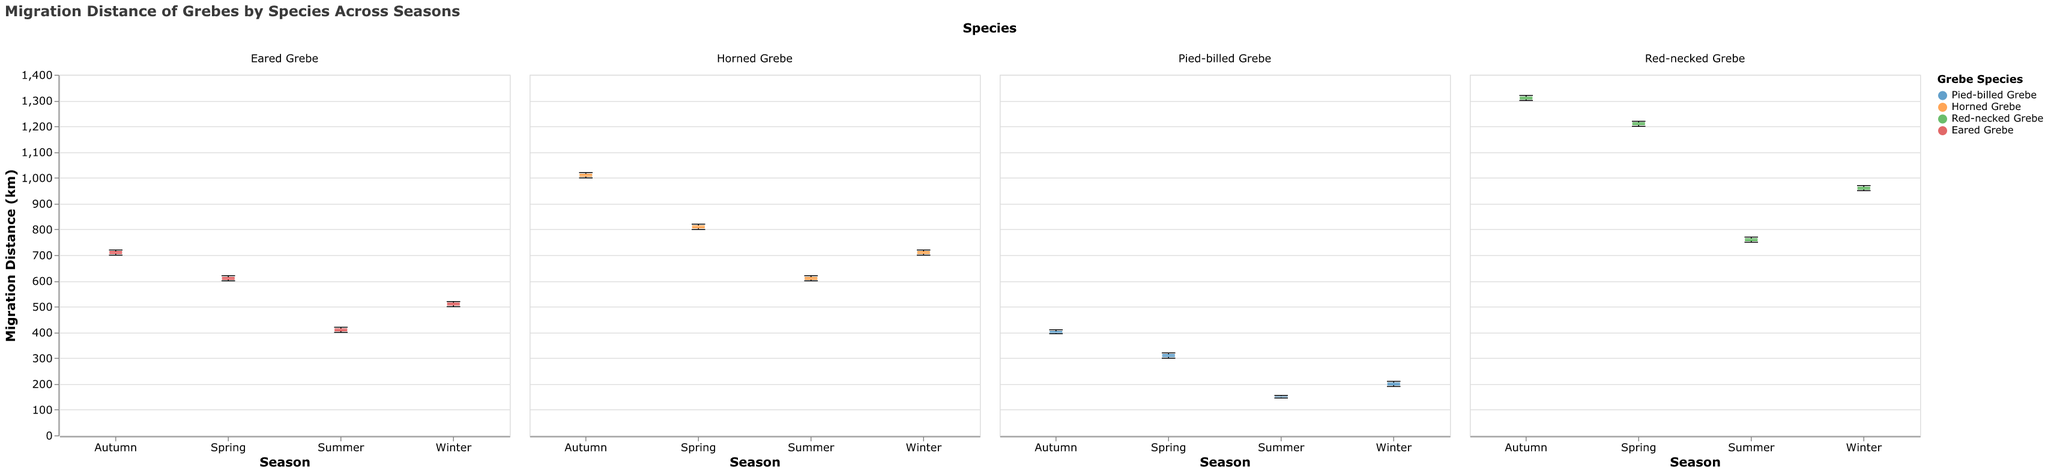Which species shows the highest median migration distance? The box plot's central line represents the median migration distance for each species across different seasons. The Red-necked Grebe has the highest median value compared to the other species.
Answer: Red-necked Grebe In which season does the Pied-billed Grebe have the lowest migration distance? By observing the box plots for the Pied-billed Grebe, the Summer season box plot has the lowest range of migration distances.
Answer: Summer What is the median migration distance for the Eared Grebe during Autumn? Find the Autumn box plot for the Eared Grebe and look at the central line for its median value. The median line is at 710 km.
Answer: 710 km Among all seasons, which species has the widest range of migration distances? The range is indicated by the length from the minimum to the maximum value in each box plot. The Red-necked Grebe in Autumn has a wider spread compared to other species and seasons.
Answer: Red-necked Grebe in Autumn How does the migration distance of Horned Grebes in Winter compare to those in Summer? To compare, look at the box plots for Winter and Summer for Horned Grebes. Winter migration distances are higher, as the boxes are positioned higher on the y-axis compared to Summer.
Answer: Winter distances are higher Which season shows the highest median migration distance across all species? Look at the median lines of all species in each season's box plots. The highest median lines appear during Autumn for species like Red-necked Grebe and Horned Grebe.
Answer: Autumn Are Eared Grebes' migration distances in Spring higher or lower than those in Winter? Compare the box plot for Eared Grebes in Spring with the one in Winter. The Spring distances are higher, as indicated by the overall higher position of the box plot.
Answer: Higher What is the range of migration distances for Pied-billed Grebes in Autumn? Find the minimum and maximum points of the Autumn box plot for Pied-billed Grebes. The minimum value is 395 km, and the maximum value is 410 km, so the range is 410 - 395 = 15 km.
Answer: 15 km Which species has the lowest median migration distance in Summer? Look at the median lines of all species in Summer. The Pied-billed Grebe has the lowest median distance among them.
Answer: Pied-billed Grebe 